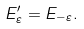Convert formula to latex. <formula><loc_0><loc_0><loc_500><loc_500>E ^ { \prime } _ { \varepsilon } = E _ { - \varepsilon } .</formula> 